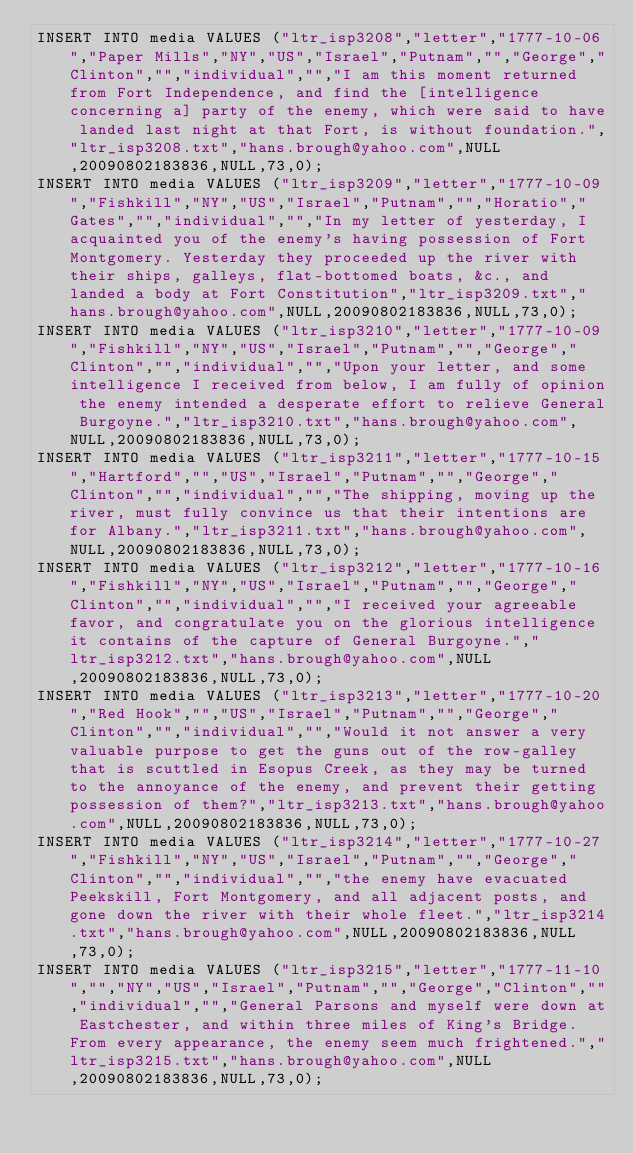<code> <loc_0><loc_0><loc_500><loc_500><_SQL_>INSERT INTO media VALUES ("ltr_isp3208","letter","1777-10-06","Paper Mills","NY","US","Israel","Putnam","","George","Clinton","","individual","","I am this moment returned from Fort Independence, and find the [intelligence concerning a] party of the enemy, which were said to have landed last night at that Fort, is without foundation.","ltr_isp3208.txt","hans.brough@yahoo.com",NULL,20090802183836,NULL,73,0);
INSERT INTO media VALUES ("ltr_isp3209","letter","1777-10-09","Fishkill","NY","US","Israel","Putnam","","Horatio","Gates","","individual","","In my letter of yesterday, I acquainted you of the enemy's having possession of Fort Montgomery. Yesterday they proceeded up the river with their ships, galleys, flat-bottomed boats, &c., and landed a body at Fort Constitution","ltr_isp3209.txt","hans.brough@yahoo.com",NULL,20090802183836,NULL,73,0);
INSERT INTO media VALUES ("ltr_isp3210","letter","1777-10-09","Fishkill","NY","US","Israel","Putnam","","George","Clinton","","individual","","Upon your letter, and some intelligence I received from below, I am fully of opinion the enemy intended a desperate effort to relieve General Burgoyne.","ltr_isp3210.txt","hans.brough@yahoo.com",NULL,20090802183836,NULL,73,0);
INSERT INTO media VALUES ("ltr_isp3211","letter","1777-10-15","Hartford","","US","Israel","Putnam","","George","Clinton","","individual","","The shipping, moving up the river, must fully convince us that their intentions are for Albany.","ltr_isp3211.txt","hans.brough@yahoo.com",NULL,20090802183836,NULL,73,0);
INSERT INTO media VALUES ("ltr_isp3212","letter","1777-10-16","Fishkill","NY","US","Israel","Putnam","","George","Clinton","","individual","","I received your agreeable favor, and congratulate you on the glorious intelligence it contains of the capture of General Burgoyne.","ltr_isp3212.txt","hans.brough@yahoo.com",NULL,20090802183836,NULL,73,0);
INSERT INTO media VALUES ("ltr_isp3213","letter","1777-10-20","Red Hook","","US","Israel","Putnam","","George","Clinton","","individual","","Would it not answer a very valuable purpose to get the guns out of the row-galley that is scuttled in Esopus Creek, as they may be turned to the annoyance of the enemy, and prevent their getting possession of them?","ltr_isp3213.txt","hans.brough@yahoo.com",NULL,20090802183836,NULL,73,0);
INSERT INTO media VALUES ("ltr_isp3214","letter","1777-10-27","Fishkill","NY","US","Israel","Putnam","","George","Clinton","","individual","","the enemy have evacuated Peekskill, Fort Montgomery, and all adjacent posts, and gone down the river with their whole fleet.","ltr_isp3214.txt","hans.brough@yahoo.com",NULL,20090802183836,NULL,73,0);
INSERT INTO media VALUES ("ltr_isp3215","letter","1777-11-10","","NY","US","Israel","Putnam","","George","Clinton","","individual","","General Parsons and myself were down at Eastchester, and within three miles of King's Bridge. From every appearance, the enemy seem much frightened.","ltr_isp3215.txt","hans.brough@yahoo.com",NULL,20090802183836,NULL,73,0);
</code> 